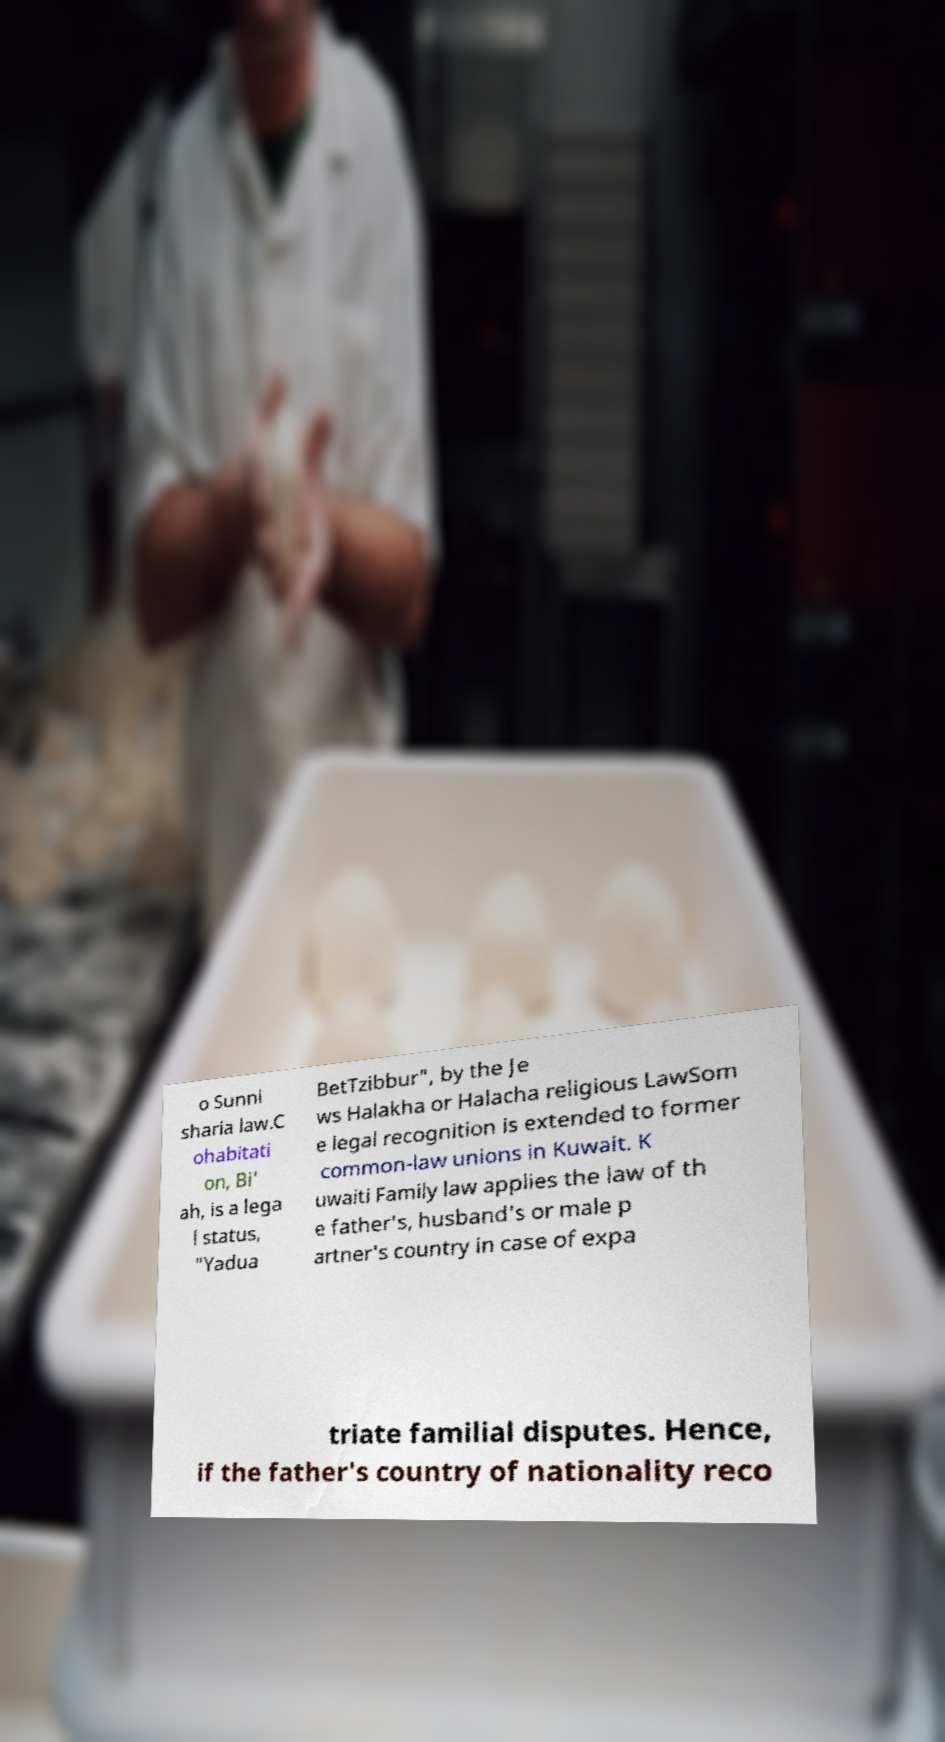Can you read and provide the text displayed in the image?This photo seems to have some interesting text. Can you extract and type it out for me? o Sunni sharia law.C ohabitati on, Bi' ah, is a lega l status, "Yadua BetTzibbur", by the Je ws Halakha or Halacha religious LawSom e legal recognition is extended to former common-law unions in Kuwait. K uwaiti Family law applies the law of th e father's, husband's or male p artner's country in case of expa triate familial disputes. Hence, if the father's country of nationality reco 